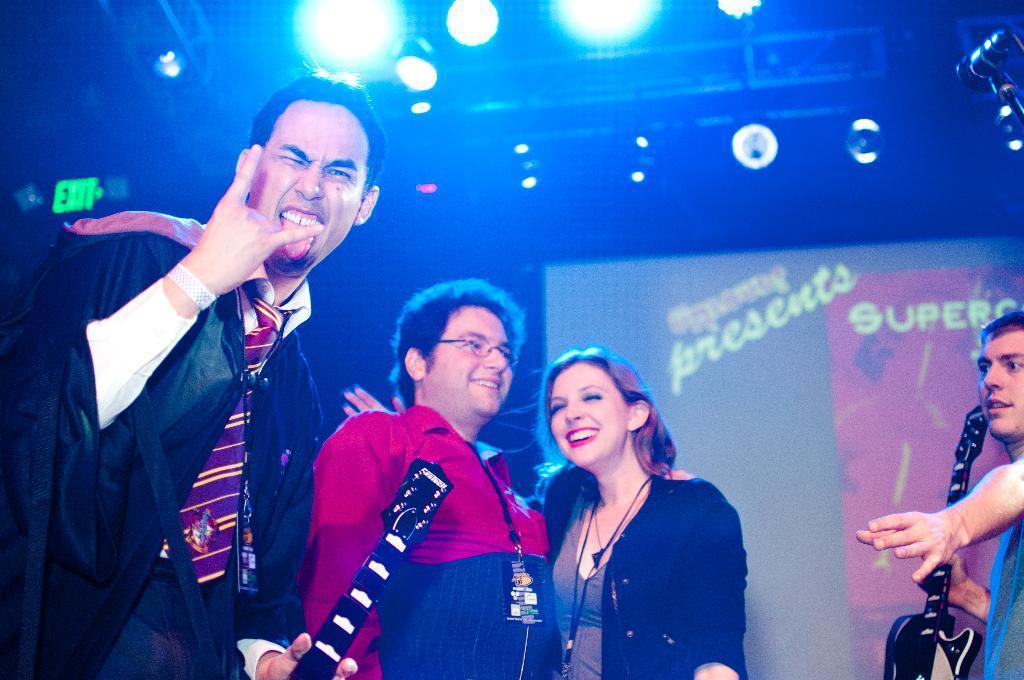Could you give a brief overview of what you see in this image? Three people are standing and smiling and at the top it's a light. 